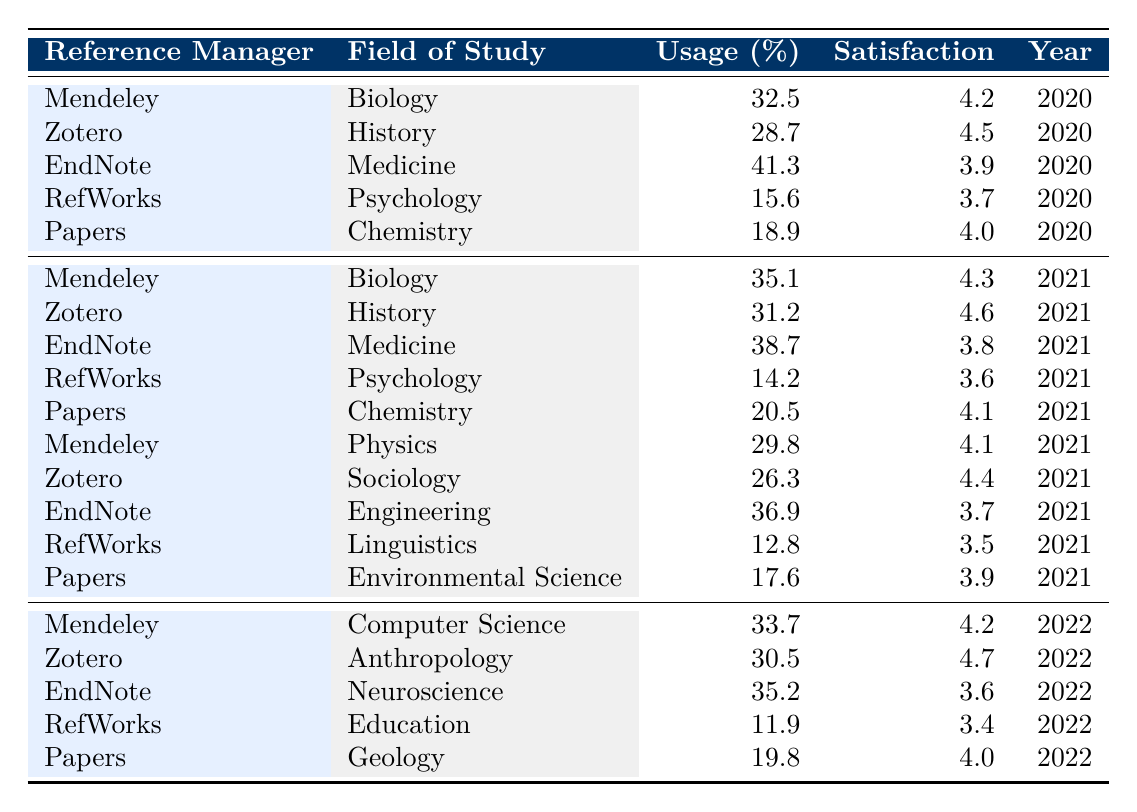What is the usage percentage of EndNote in Medicine for the year 2020? According to the table, EndNote has a usage percentage of 41.3% in the Medicine field for the year 2020.
Answer: 41.3% Which reference manager had the highest user satisfaction score in 2021? By examining the satisfaction scores for 2021, Zotero had the highest score of 4.6.
Answer: Zotero What is the average usage percentage of Mendeley across all years in the table? The usage percentages of Mendeley are 32.5 in 2020, 35.1 in 2021, and 33.7 in 2022. The sum is (32.5 + 35.1 + 33.7) = 101.3, and there are 3 data points, so the average is 101.3 / 3 ≈ 33.77.
Answer: 33.77 Is the user satisfaction score for RefWorks in 2022 higher than that in 2021? RefWorks has a user satisfaction score of 3.4 in 2022 and 3.5 in 2021. Therefore, the score in 2022 is not higher than in 2021.
Answer: No What is the difference in usage percentage for Papers between 2021 and 2022? The usage percentage for Papers in 2021 is 20.5 and in 2022 is 19.8. The difference is 20.5 - 19.8 = 0.7.
Answer: 0.7 How many fields of study show an increase in Mendeley's usage percentage from 2020 to 2021? Mendeley's usage percentage increased from 32.5 (2020) to 35.1 (2021) in Biology, but the usage in other fields stays the same or decreases, so the increase is only noted for Biology which accounts for 1 field.
Answer: 1 Which reference manager shows the lowest user satisfaction score in 2022? The table indicates that RefWorks has the lowest user satisfaction score of 3.4 in 2022.
Answer: RefWorks What is the highest recorded usage percentage for Zotero across all years listed? Looking at the table, the usage percentages for Zotero are 28.7 (2020), 31.2 (2021), and 30.5 (2022). The highest recorded is 31.2 in 2021.
Answer: 31.2 Which field of study had the lowest usage percentage in the year 2021? From the data provided, RefWorks in Linguistics had the lowest usage percentage of 12.8 in 2021.
Answer: Linguistics What is the median user satisfaction score for all the reference managers in 2020? The scores for 2020 are 4.2, 4.5, 3.9, 3.7, and 4.0; sorting these gives 3.7, 3.9, 4.0, 4.2, 4.5. The median, which is the middle number, is 4.0.
Answer: 4.0 How does the average user satisfaction score of Papers compare to that of RefWorks in 2021? Papers had a satisfaction score of 4.1 in 2021, while RefWorks had 3.6. The average for Papers is higher than that for RefWorks, indicating better user satisfaction for Papers.
Answer: Higher for Papers 